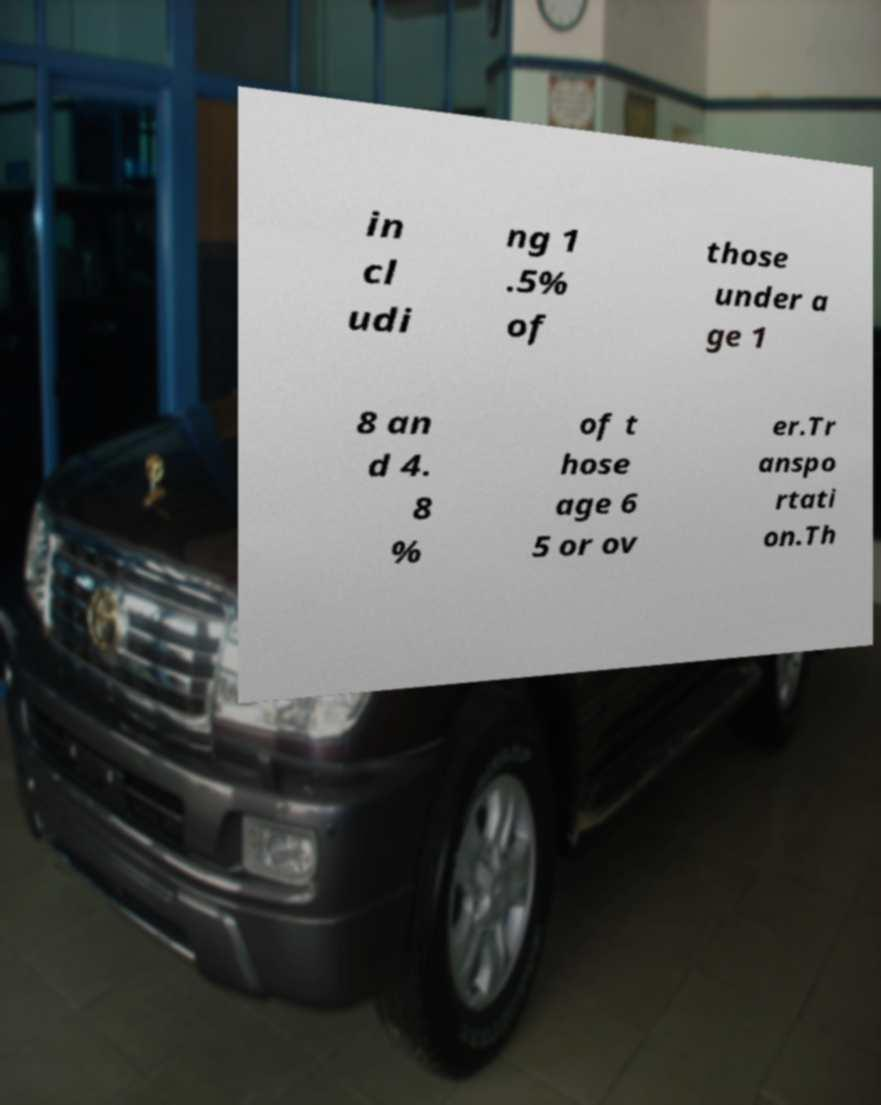What messages or text are displayed in this image? I need them in a readable, typed format. in cl udi ng 1 .5% of those under a ge 1 8 an d 4. 8 % of t hose age 6 5 or ov er.Tr anspo rtati on.Th 